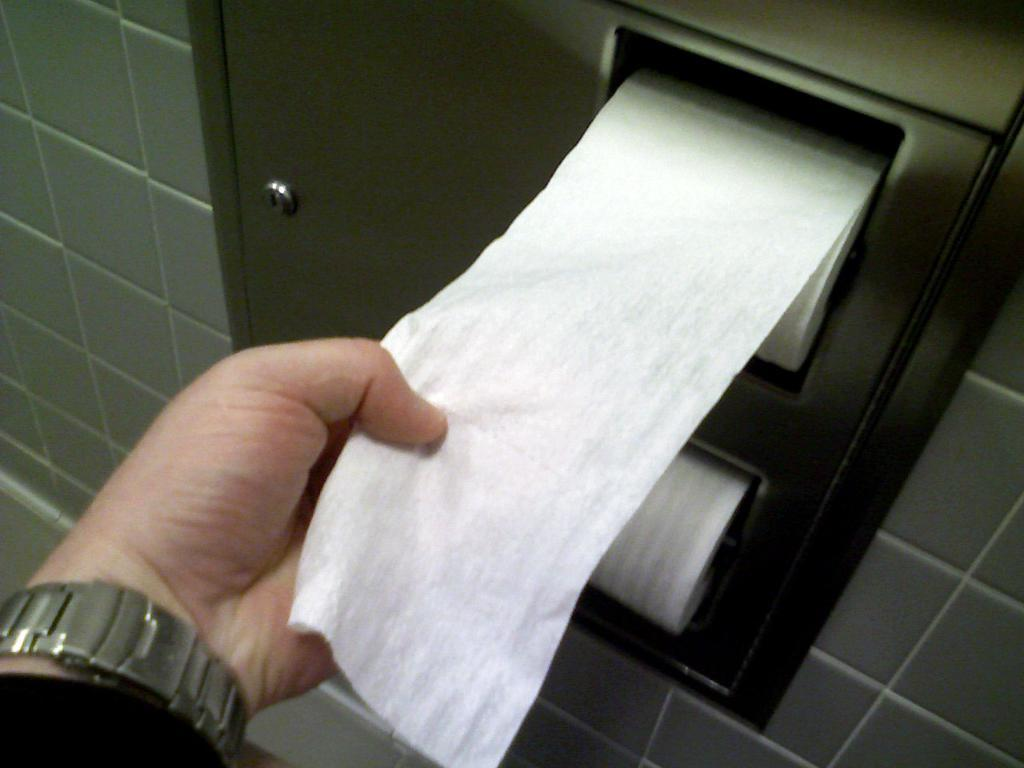What part of the person's body can be seen in the image? There is a person's hand in the image. What is the person doing with their hand? The person is pulling a tissue roll. What can be seen behind the person in the image? There is a wall visible in the image. What is the person's mind doing in the image? The person's mind is not visible in the image, as it is an abstract concept and not a physical object. 